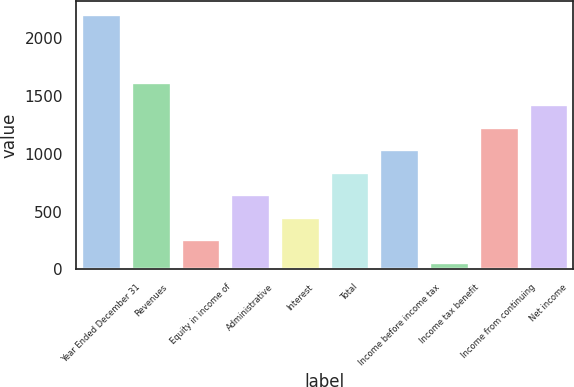Convert chart to OTSL. <chart><loc_0><loc_0><loc_500><loc_500><bar_chart><fcel>Year Ended December 31<fcel>Revenues<fcel>Equity in income of<fcel>Administrative<fcel>Interest<fcel>Total<fcel>Income before income tax<fcel>Income tax benefit<fcel>Income from continuing<fcel>Net income<nl><fcel>2209.9<fcel>1625.2<fcel>260.9<fcel>650.7<fcel>455.8<fcel>845.6<fcel>1040.5<fcel>66<fcel>1235.4<fcel>1430.3<nl></chart> 